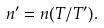Convert formula to latex. <formula><loc_0><loc_0><loc_500><loc_500>n ^ { \prime } = n ( T / T ^ { \prime } ) .</formula> 